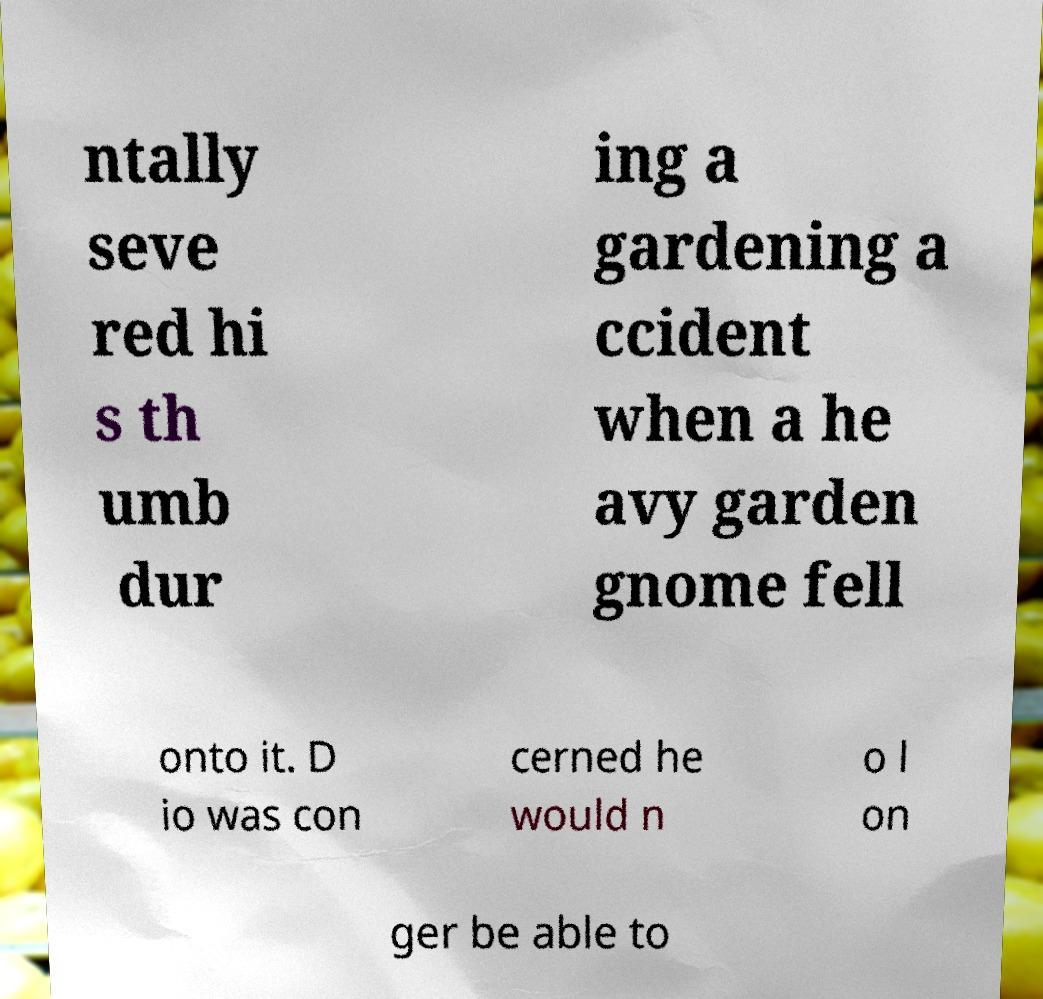Could you extract and type out the text from this image? ntally seve red hi s th umb dur ing a gardening a ccident when a he avy garden gnome fell onto it. D io was con cerned he would n o l on ger be able to 